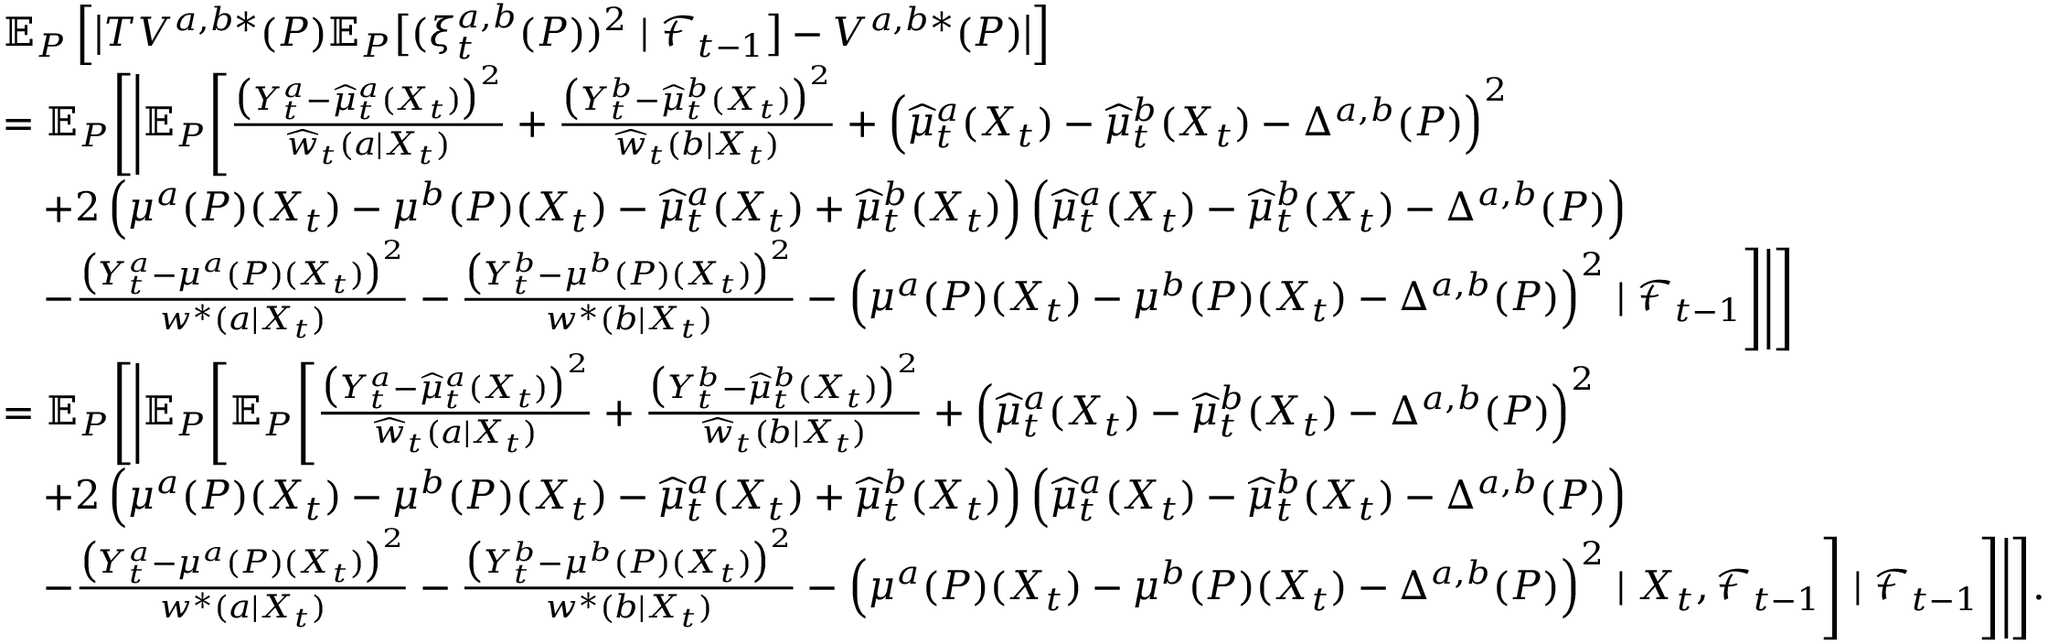<formula> <loc_0><loc_0><loc_500><loc_500>\begin{array} { r l } & { \mathbb { E } _ { P } \left [ \left | T V ^ { a , b * } ( P ) \mathbb { E } _ { P } \left [ ( \xi _ { t } ^ { a , b } ( P ) ) ^ { 2 } | \mathcal { F } _ { t - 1 } \right ] - V ^ { a , b * } ( P ) \right | \right ] } \\ & { = \mathbb { E } _ { P } \left [ \left | \mathbb { E } _ { P } \left [ \frac { \left ( Y _ { t } ^ { a } - \widehat { \mu } _ { t } ^ { a } ( X _ { t } ) \right ) ^ { 2 } } { \widehat { w } _ { t } ( a | X _ { t } ) } + \frac { \left ( Y _ { t } ^ { b } - \widehat { \mu } _ { t } ^ { b } ( X _ { t } ) \right ) ^ { 2 } } { \widehat { w } _ { t } ( b | X _ { t } ) } + \left ( \widehat { \mu } _ { t } ^ { a } ( X _ { t } ) - \widehat { \mu } _ { t } ^ { b } ( X _ { t } ) - \Delta ^ { a , b } ( P ) \right ) ^ { 2 } } \\ & { \quad + 2 \left ( \mu ^ { a } ( P ) ( X _ { t } ) - \mu ^ { b } ( P ) ( X _ { t } ) - \widehat { \mu } _ { t } ^ { a } ( X _ { t } ) + \widehat { \mu } _ { t } ^ { b } ( X _ { t } ) \right ) \left ( \widehat { \mu } _ { t } ^ { a } ( X _ { t } ) - \widehat { \mu } _ { t } ^ { b } ( X _ { t } ) - \Delta ^ { a , b } ( P ) \right ) } \\ & { \quad - \frac { \left ( Y _ { t } ^ { a } - \mu ^ { a } ( P ) ( X _ { t } ) \right ) ^ { 2 } } { w ^ { * } ( a | X _ { t } ) } - \frac { \left ( Y _ { t } ^ { b } - \mu ^ { b } ( P ) ( X _ { t } ) \right ) ^ { 2 } } { w ^ { * } ( b | X _ { t } ) } - \left ( \mu ^ { a } ( P ) ( X _ { t } ) - \mu ^ { b } ( P ) ( X _ { t } ) - \Delta ^ { a , b } ( P ) \right ) ^ { 2 } | \mathcal { F } _ { t - 1 } \right ] \right | \right ] } \\ & { = \mathbb { E } _ { P } \left [ \left | \mathbb { E } _ { P } \left [ \mathbb { E } _ { P } \left [ \frac { \left ( Y _ { t } ^ { a } - \widehat { \mu } _ { t } ^ { a } ( X _ { t } ) \right ) ^ { 2 } } { \widehat { w } _ { t } ( a | X _ { t } ) } + \frac { \left ( Y _ { t } ^ { b } - \widehat { \mu } _ { t } ^ { b } ( X _ { t } ) \right ) ^ { 2 } } { \widehat { w } _ { t } ( b | X _ { t } ) } + \left ( \widehat { \mu } _ { t } ^ { a } ( X _ { t } ) - \widehat { \mu } _ { t } ^ { b } ( X _ { t } ) - \Delta ^ { a , b } ( P ) \right ) ^ { 2 } } \\ & { \quad + 2 \left ( \mu ^ { a } ( P ) ( X _ { t } ) - \mu ^ { b } ( P ) ( X _ { t } ) - \widehat { \mu } _ { t } ^ { a } ( X _ { t } ) + \widehat { \mu } _ { t } ^ { b } ( X _ { t } ) \right ) \left ( \widehat { \mu } _ { t } ^ { a } ( X _ { t } ) - \widehat { \mu } _ { t } ^ { b } ( X _ { t } ) - \Delta ^ { a , b } ( P ) \right ) } \\ & { \quad - \frac { \left ( Y _ { t } ^ { a } - \mu ^ { a } ( P ) ( X _ { t } ) \right ) ^ { 2 } } { w ^ { * } ( a | X _ { t } ) } - \frac { \left ( Y _ { t } ^ { b } - \mu ^ { b } ( P ) ( X _ { t } ) \right ) ^ { 2 } } { w ^ { * } ( b | X _ { t } ) } - \left ( \mu ^ { a } ( P ) ( X _ { t } ) - \mu ^ { b } ( P ) ( X _ { t } ) - \Delta ^ { a , b } ( P ) \right ) ^ { 2 } | X _ { t } , \mathcal { F } _ { t - 1 } \right ] | \mathcal { F } _ { t - 1 } \right ] \right | \right ] . } \end{array}</formula> 